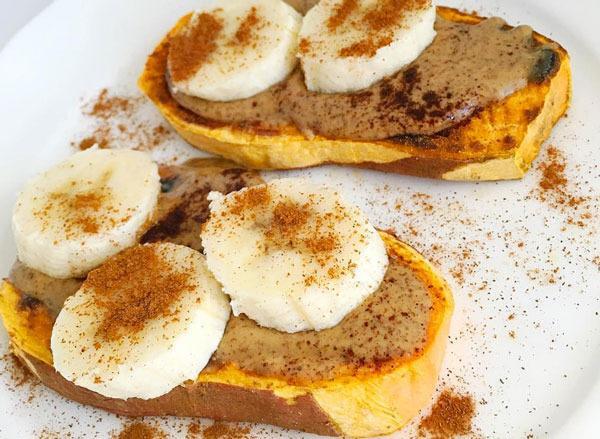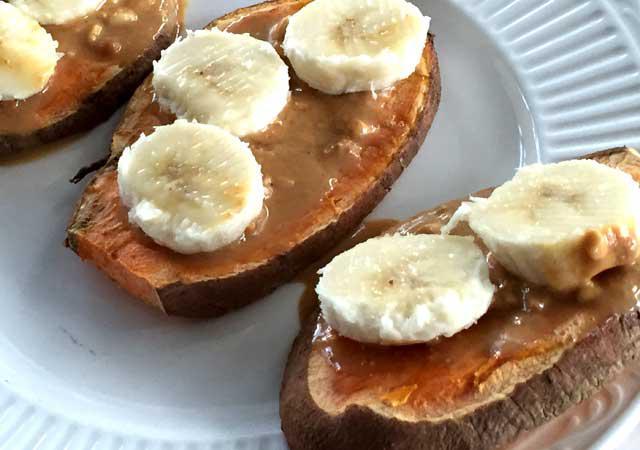The first image is the image on the left, the second image is the image on the right. Considering the images on both sides, is "Twenty one or fewer banana slices are visible." valid? Answer yes or no. Yes. The first image is the image on the left, the second image is the image on the right. For the images displayed, is the sentence "There are at least five pieces of bread with pieces of banana on them." factually correct? Answer yes or no. Yes. 